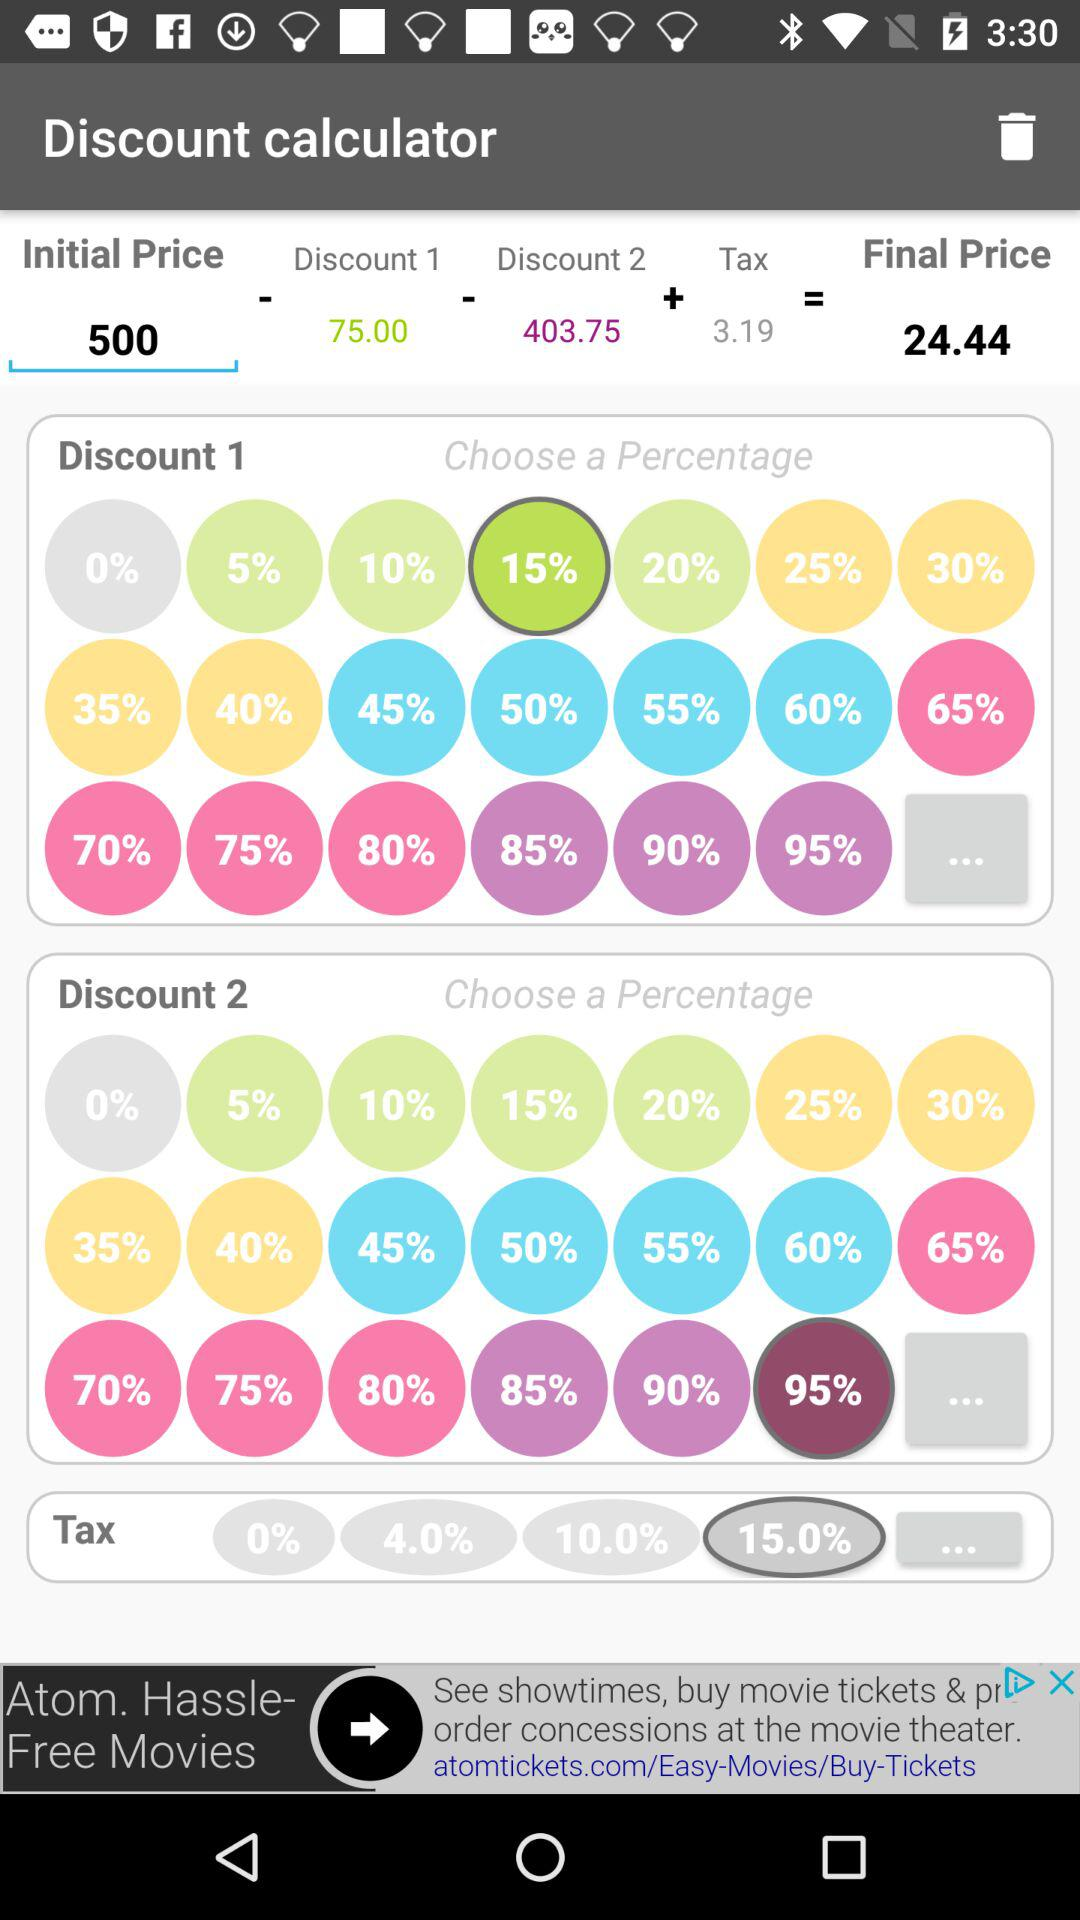What's the tax percentage? The tax percentage is 15. 